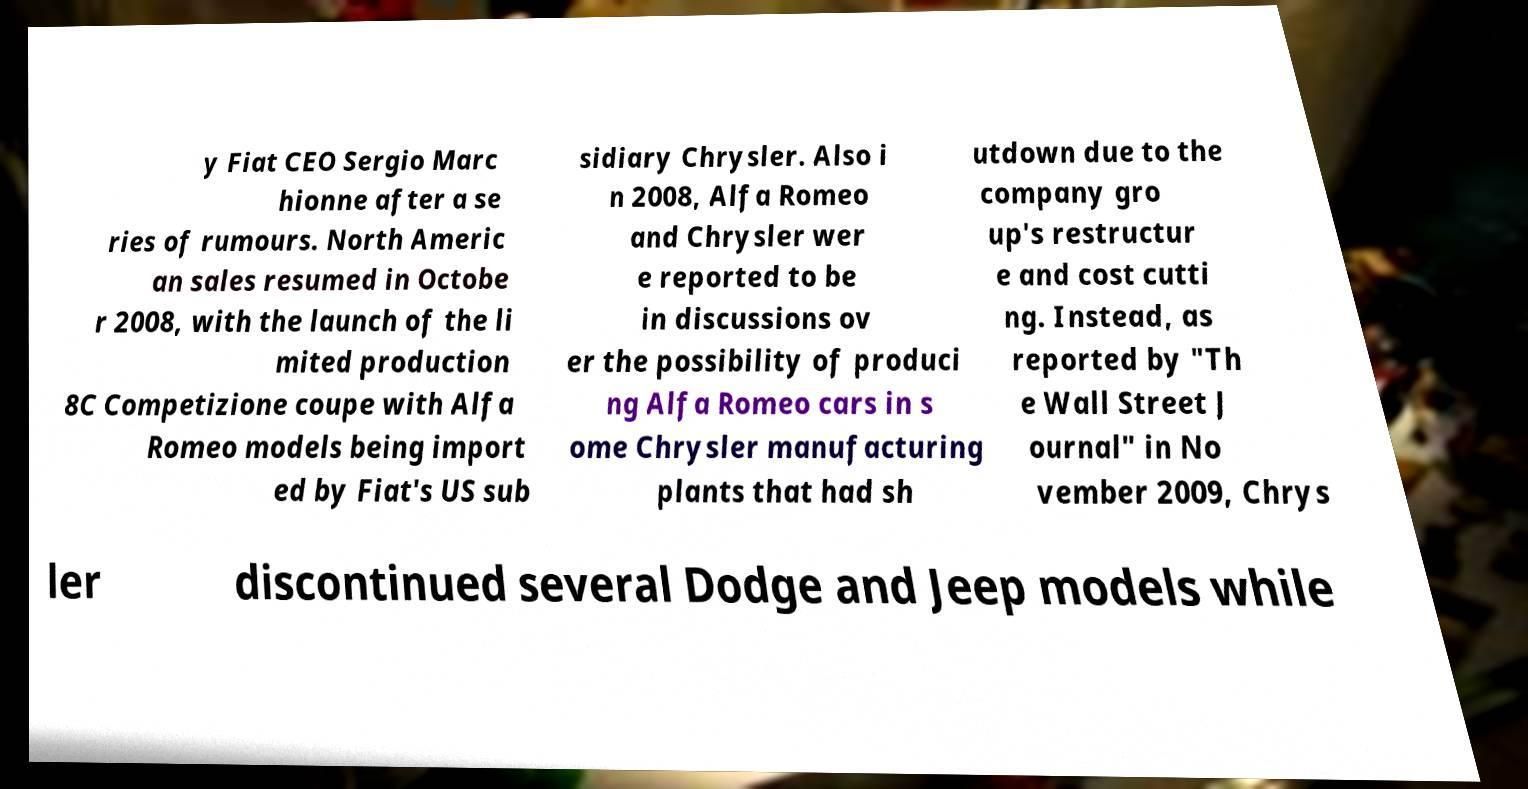I need the written content from this picture converted into text. Can you do that? y Fiat CEO Sergio Marc hionne after a se ries of rumours. North Americ an sales resumed in Octobe r 2008, with the launch of the li mited production 8C Competizione coupe with Alfa Romeo models being import ed by Fiat's US sub sidiary Chrysler. Also i n 2008, Alfa Romeo and Chrysler wer e reported to be in discussions ov er the possibility of produci ng Alfa Romeo cars in s ome Chrysler manufacturing plants that had sh utdown due to the company gro up's restructur e and cost cutti ng. Instead, as reported by "Th e Wall Street J ournal" in No vember 2009, Chrys ler discontinued several Dodge and Jeep models while 